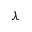<formula> <loc_0><loc_0><loc_500><loc_500>\lambda</formula> 